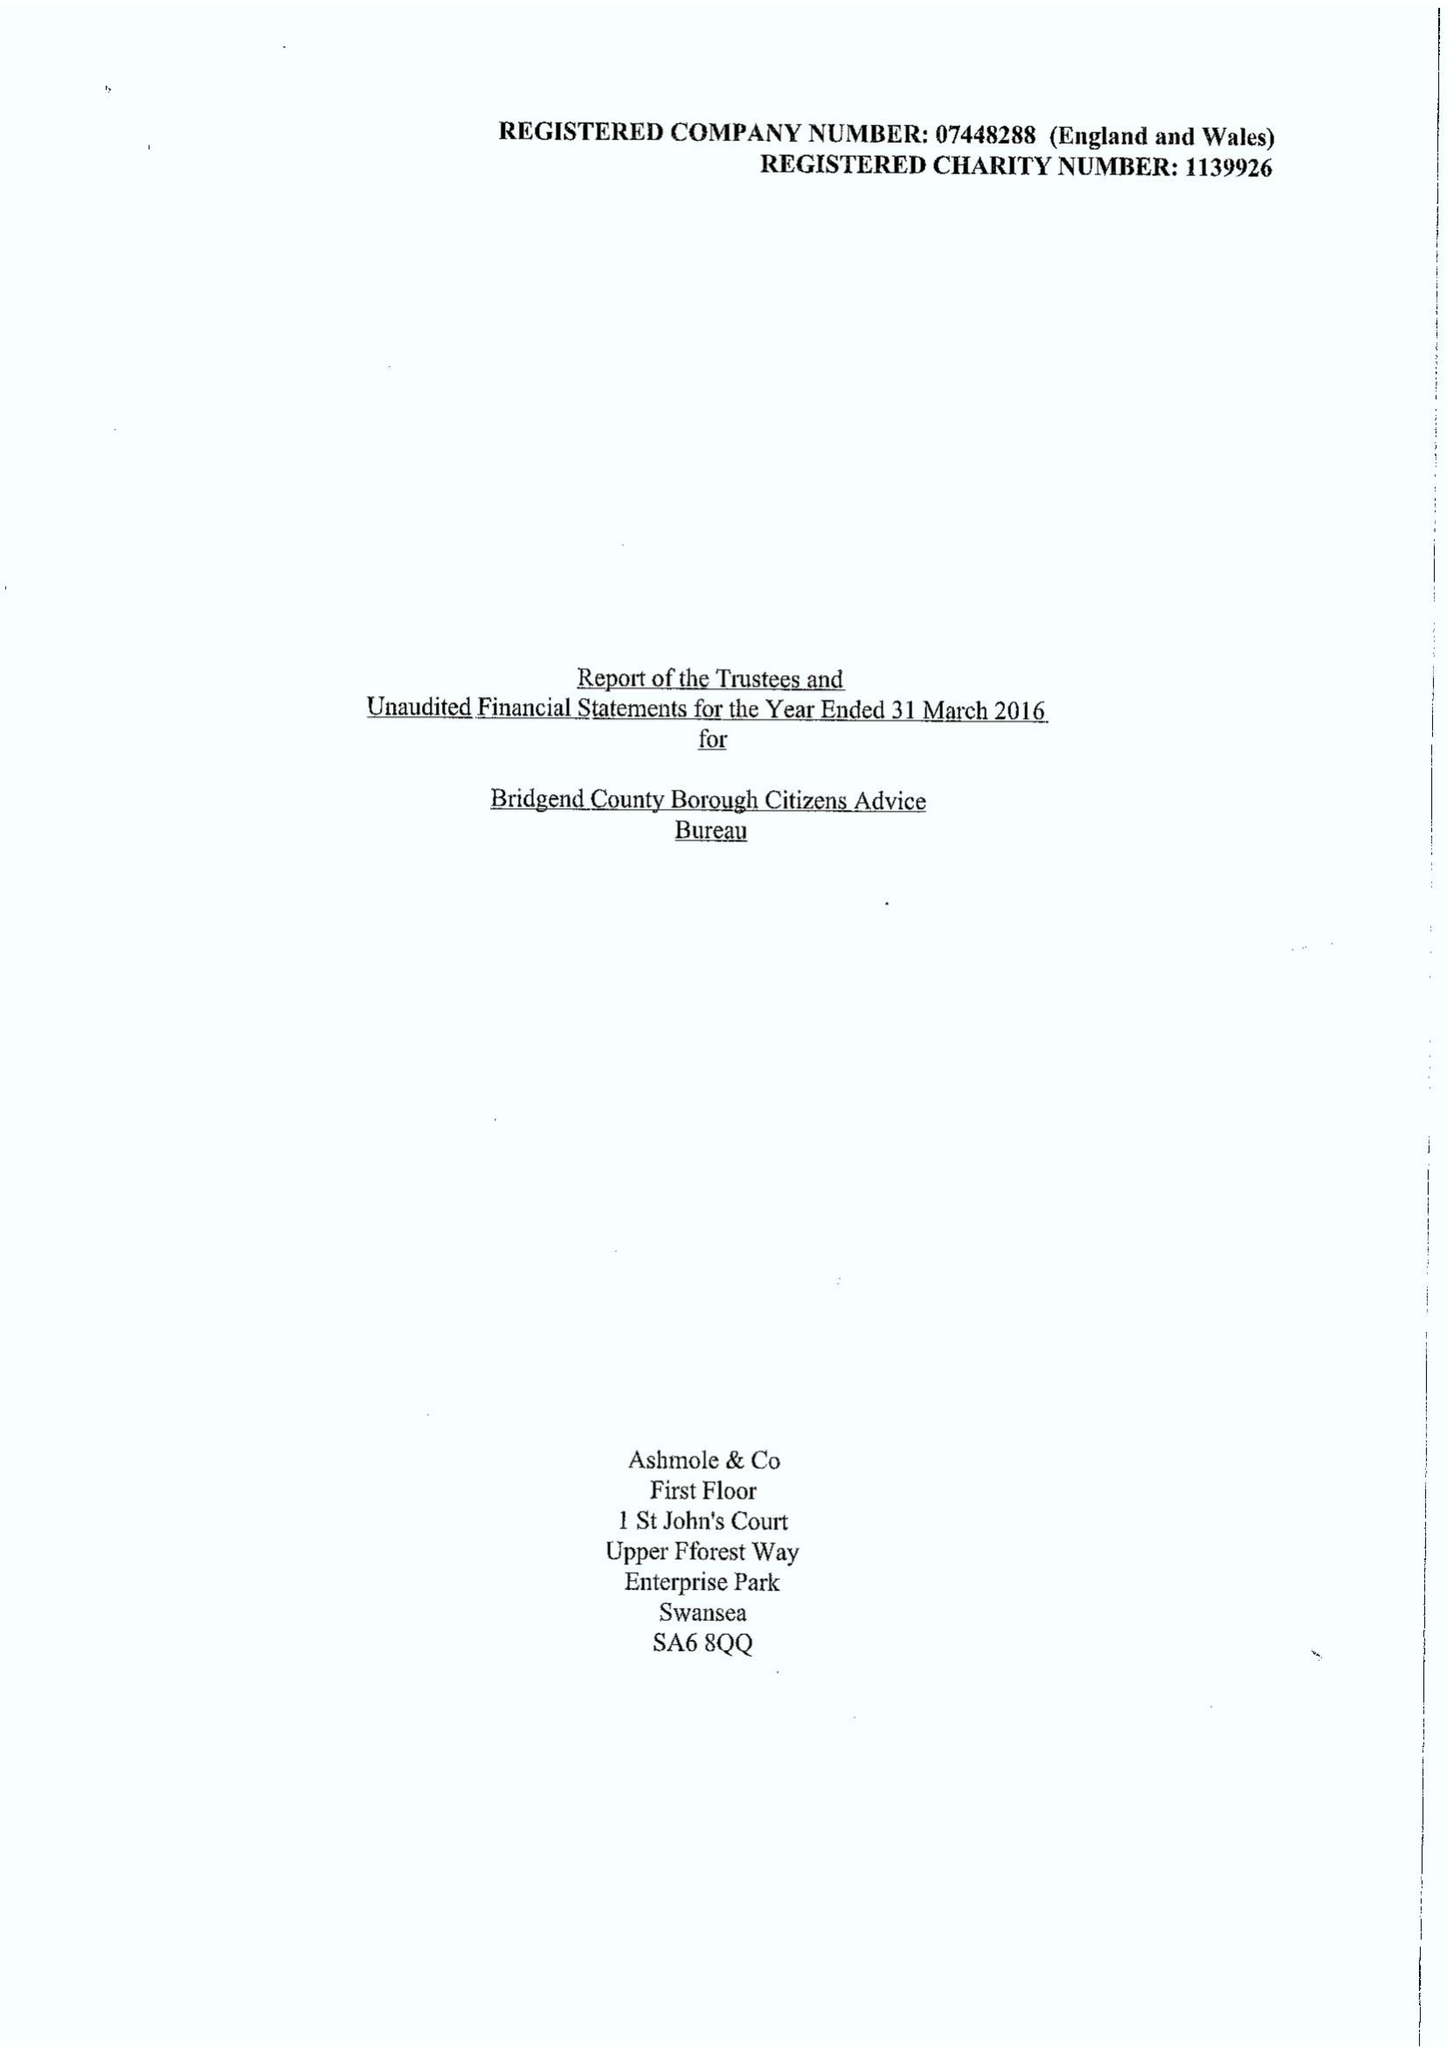What is the value for the spending_annually_in_british_pounds?
Answer the question using a single word or phrase. 452650.00 